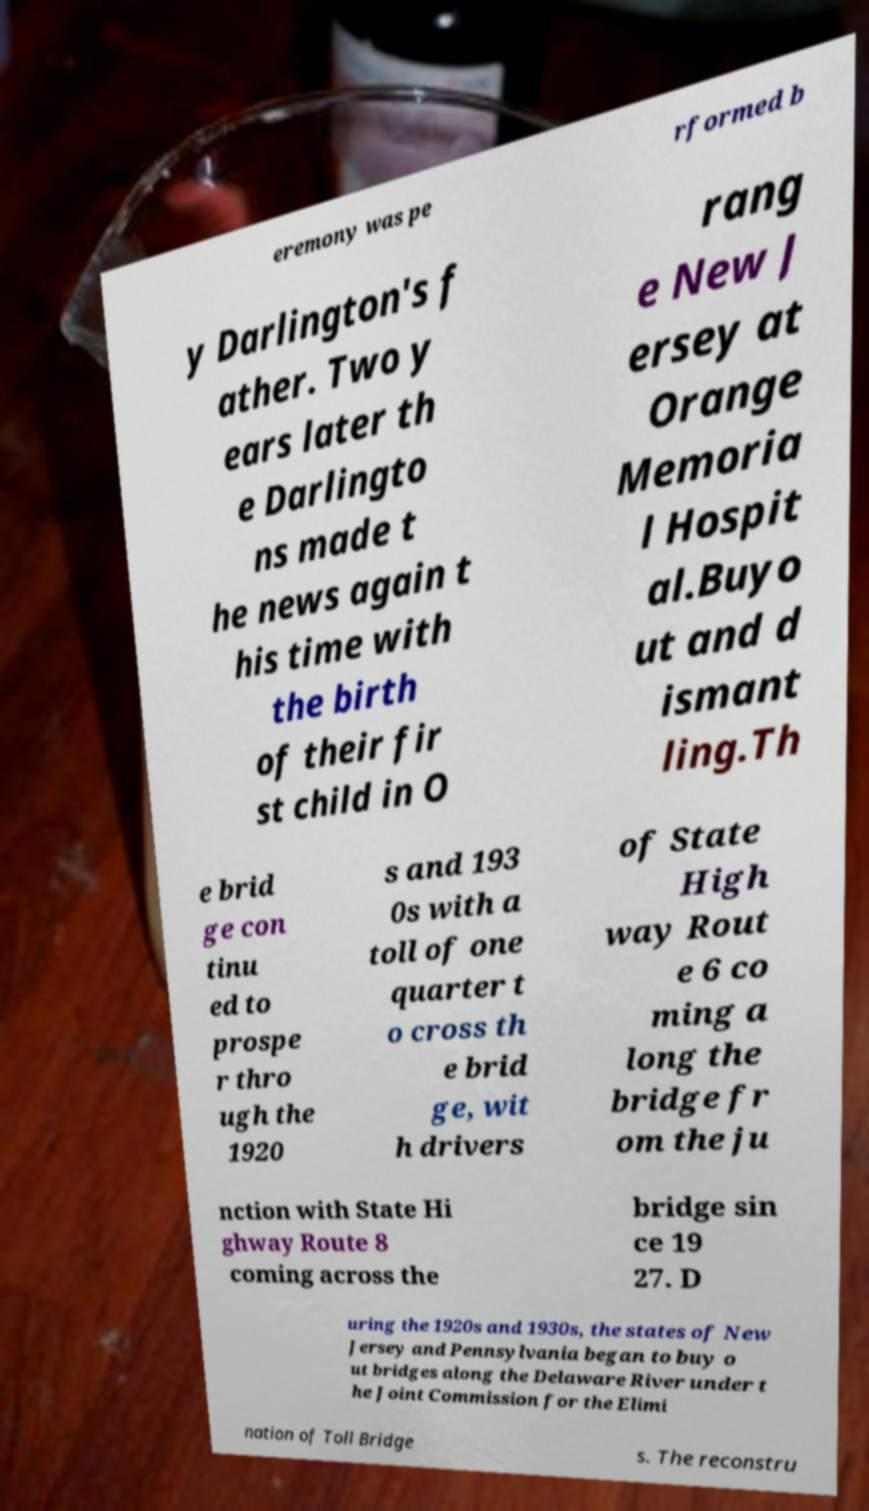There's text embedded in this image that I need extracted. Can you transcribe it verbatim? eremony was pe rformed b y Darlington's f ather. Two y ears later th e Darlingto ns made t he news again t his time with the birth of their fir st child in O rang e New J ersey at Orange Memoria l Hospit al.Buyo ut and d ismant ling.Th e brid ge con tinu ed to prospe r thro ugh the 1920 s and 193 0s with a toll of one quarter t o cross th e brid ge, wit h drivers of State High way Rout e 6 co ming a long the bridge fr om the ju nction with State Hi ghway Route 8 coming across the bridge sin ce 19 27. D uring the 1920s and 1930s, the states of New Jersey and Pennsylvania began to buy o ut bridges along the Delaware River under t he Joint Commission for the Elimi nation of Toll Bridge s. The reconstru 